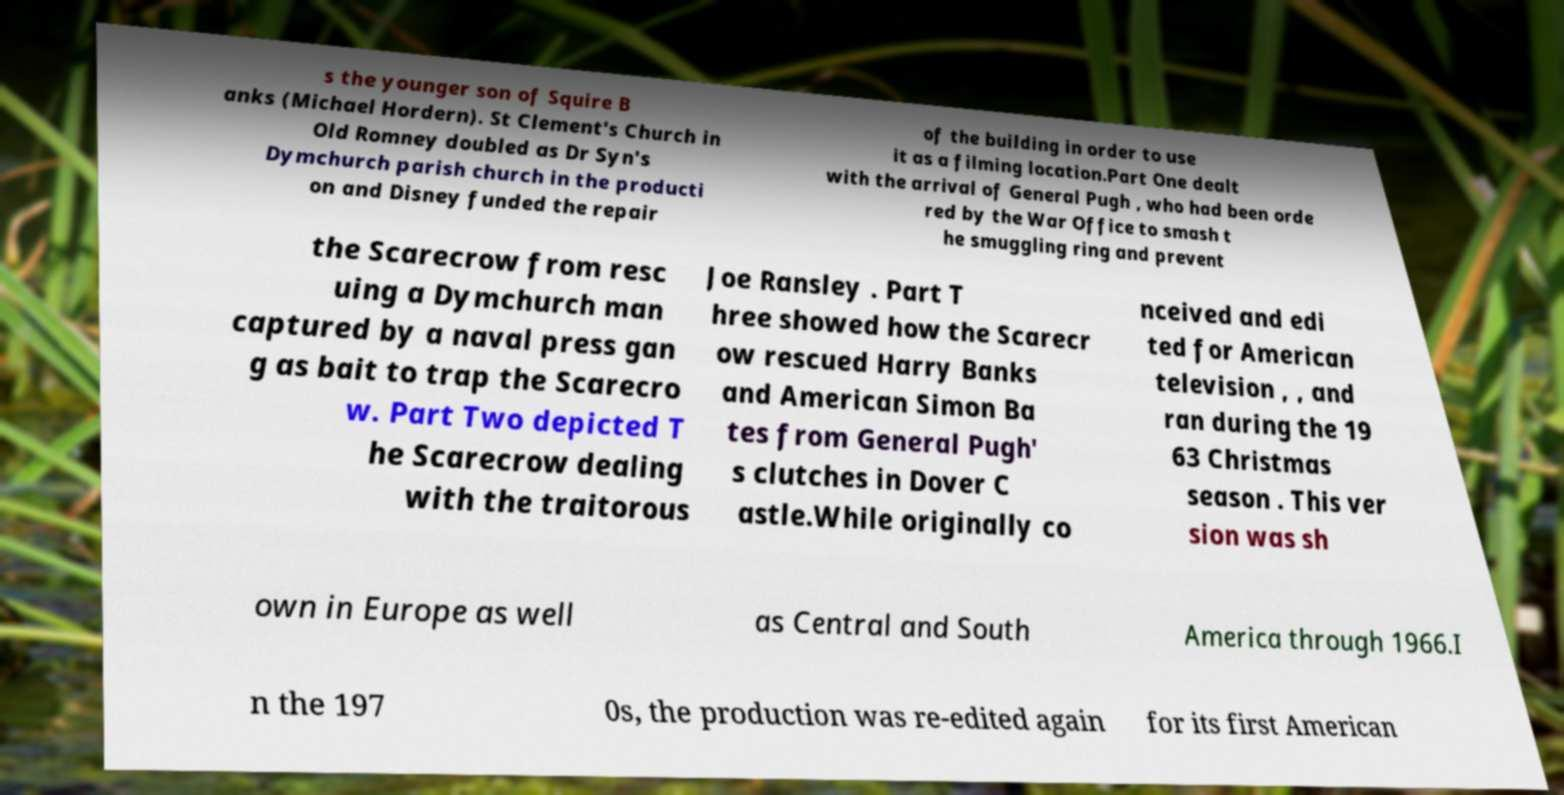There's text embedded in this image that I need extracted. Can you transcribe it verbatim? s the younger son of Squire B anks (Michael Hordern). St Clement's Church in Old Romney doubled as Dr Syn's Dymchurch parish church in the producti on and Disney funded the repair of the building in order to use it as a filming location.Part One dealt with the arrival of General Pugh , who had been orde red by the War Office to smash t he smuggling ring and prevent the Scarecrow from resc uing a Dymchurch man captured by a naval press gan g as bait to trap the Scarecro w. Part Two depicted T he Scarecrow dealing with the traitorous Joe Ransley . Part T hree showed how the Scarecr ow rescued Harry Banks and American Simon Ba tes from General Pugh' s clutches in Dover C astle.While originally co nceived and edi ted for American television , , and ran during the 19 63 Christmas season . This ver sion was sh own in Europe as well as Central and South America through 1966.I n the 197 0s, the production was re-edited again for its first American 